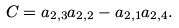<formula> <loc_0><loc_0><loc_500><loc_500>C = a _ { 2 , 3 } a _ { 2 , 2 } - a _ { 2 , 1 } a _ { 2 , 4 } .</formula> 